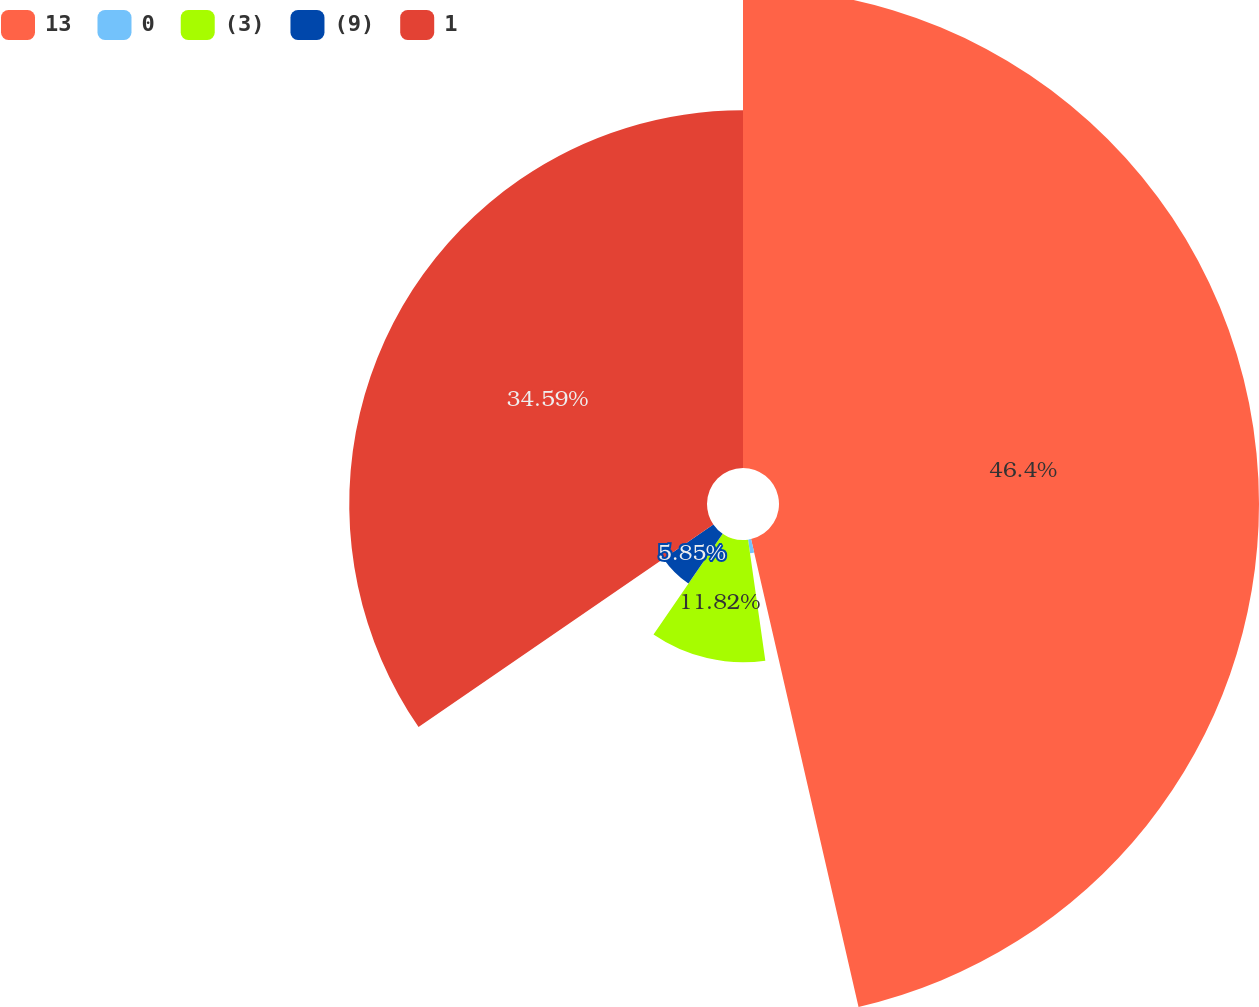Convert chart to OTSL. <chart><loc_0><loc_0><loc_500><loc_500><pie_chart><fcel>13<fcel>0<fcel>(3)<fcel>(9)<fcel>1<nl><fcel>46.41%<fcel>1.34%<fcel>11.82%<fcel>5.85%<fcel>34.59%<nl></chart> 